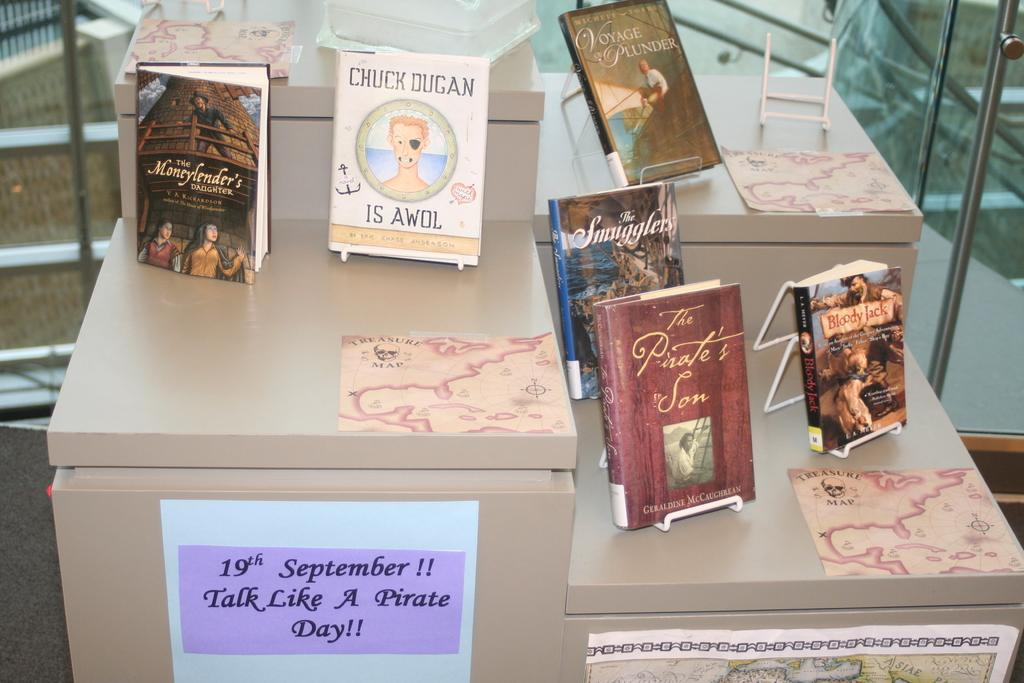<image>
Present a compact description of the photo's key features. Talk like a pirate day is coming up soon 